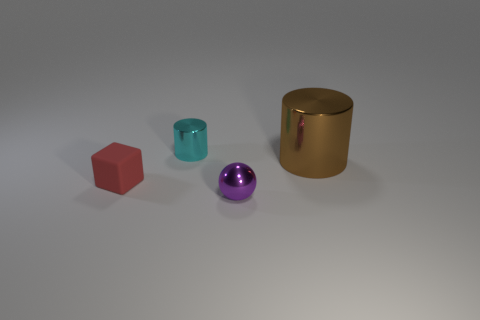Assuming these objects were part of a game, what kind of game do you think it would be? Given their simple geometric shapes and distinct colors, these objects could be part of an educational game designed to teach children about shapes, colors, and materials. Players might match each item with corresponding descriptions or group them based on similar properties. 